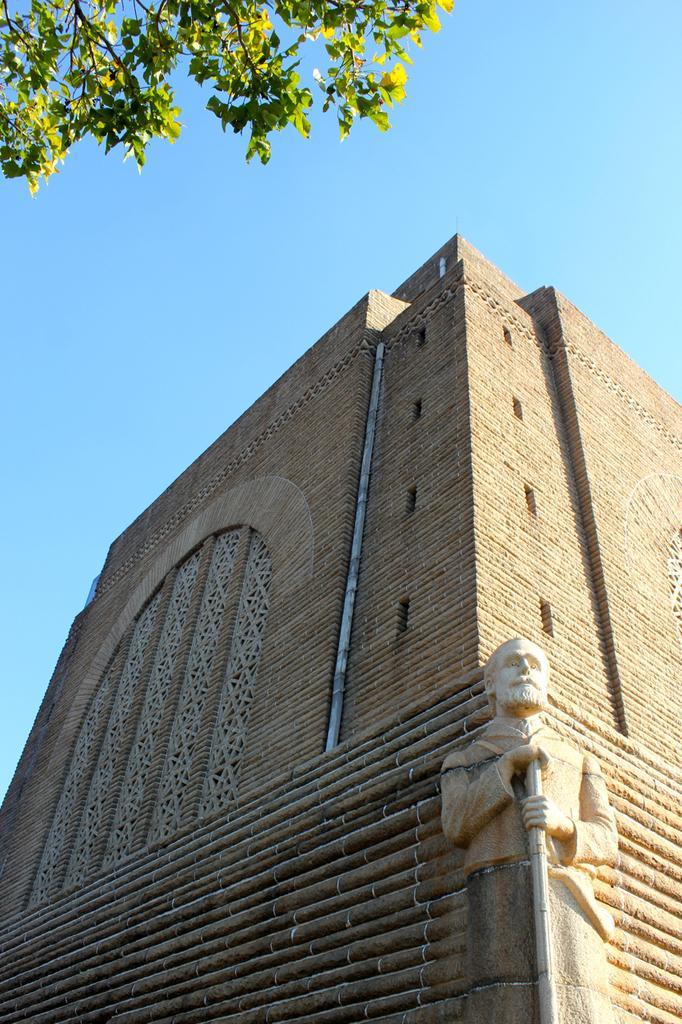Please provide a concise description of this image. This is the picture of a building. In this image there is a building and there is a sculpture on the building. At the top there is sky and there is a tree. 